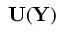<formula> <loc_0><loc_0><loc_500><loc_500>{ \mathbf U } ( { \mathbf Y } )</formula> 